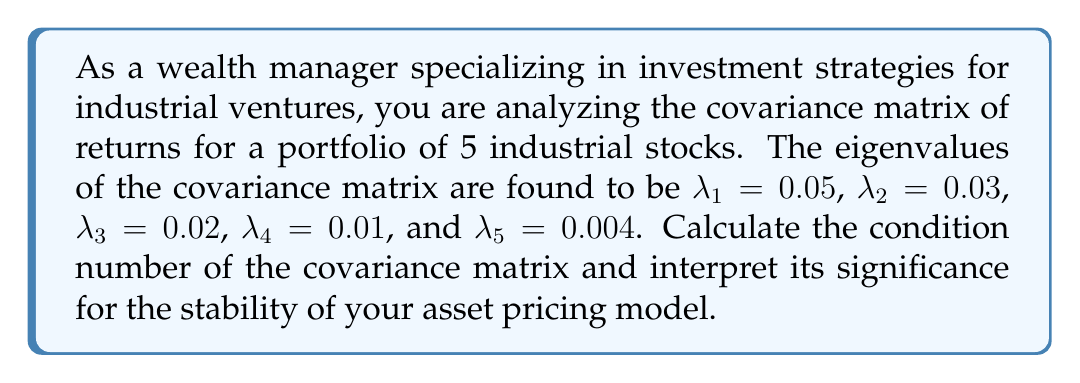Give your solution to this math problem. To solve this problem, we'll follow these steps:

1) Recall that the condition number of a matrix is defined as the ratio of the largest eigenvalue to the smallest eigenvalue:

   $$ \text{Condition Number} = \frac{\lambda_{\text{max}}}{\lambda_{\text{min}}} $$

2) From the given eigenvalues, we can identify:
   $\lambda_{\text{max}} = \lambda_1 = 0.05$
   $\lambda_{\text{min}} = \lambda_5 = 0.004$

3) Substituting these values into the condition number formula:

   $$ \text{Condition Number} = \frac{0.05}{0.004} = 12.5 $$

4) Interpretation:
   The condition number provides information about the numerical stability of the covariance matrix and its inverse. A large condition number (typically > 30) indicates that the matrix is ill-conditioned, which can lead to instability in asset pricing models that rely on this covariance matrix.

   In this case, the condition number of 12.5 is relatively low, suggesting that:
   
   a) The covariance matrix is well-conditioned.
   b) Inverting this matrix for use in asset pricing models (e.g., in the calculation of efficient portfolios) should be numerically stable.
   c) The eigenvalue spectrum is not too spread out, indicating that there isn't an overwhelming dominance of a single factor in the returns of these industrial stocks.

   This stability is beneficial for constructing robust investment strategies, as it suggests that small changes in the input data are less likely to result in large changes in the output of your asset pricing models.
Answer: The condition number of the covariance matrix is 12.5. This relatively low value indicates that the covariance matrix is well-conditioned, suggesting stability in asset pricing models using this matrix and a balanced influence of factors on the industrial stock returns. 